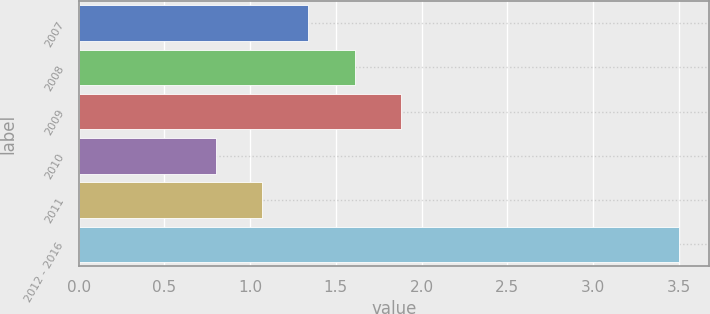Convert chart to OTSL. <chart><loc_0><loc_0><loc_500><loc_500><bar_chart><fcel>2007<fcel>2008<fcel>2009<fcel>2010<fcel>2011<fcel>2012 - 2016<nl><fcel>1.34<fcel>1.61<fcel>1.88<fcel>0.8<fcel>1.07<fcel>3.5<nl></chart> 